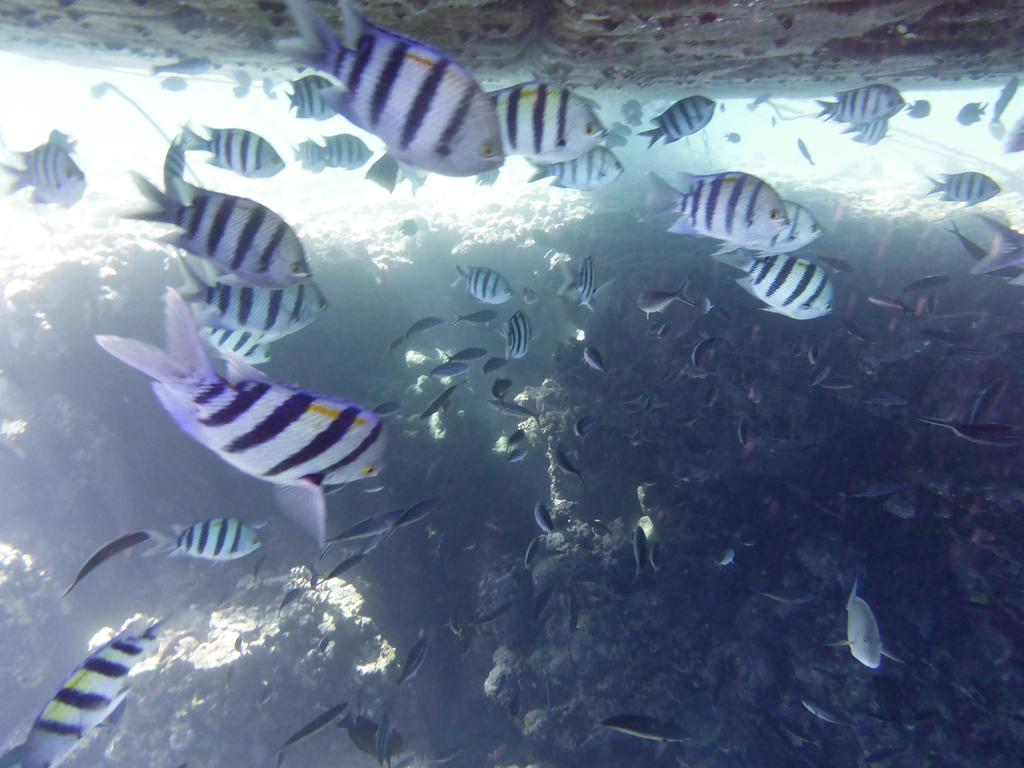What type of animals can be seen in the image? There are fishes in the image. Where are the fishes located? The fishes are in the water. What thought is the fish having on the page in the image? There is no page present in the image, and the fishes are not capable of having thoughts. 